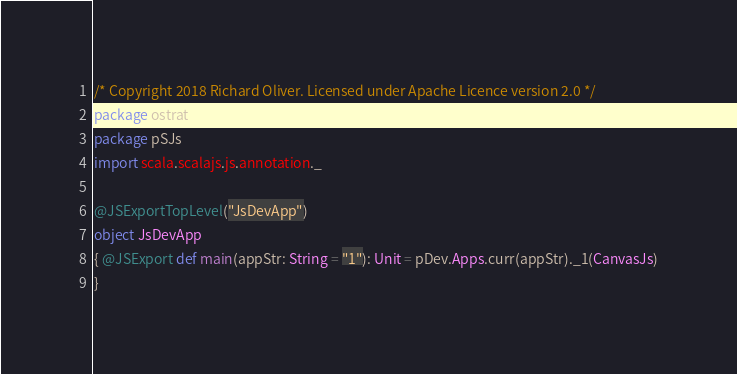Convert code to text. <code><loc_0><loc_0><loc_500><loc_500><_Scala_>/* Copyright 2018 Richard Oliver. Licensed under Apache Licence version 2.0 */
package ostrat
package pSJs
import scala.scalajs.js.annotation._

@JSExportTopLevel("JsDevApp")
object JsDevApp
{ @JSExport def main(appStr: String = "1"): Unit = pDev.Apps.curr(appStr)._1(CanvasJs)
}</code> 